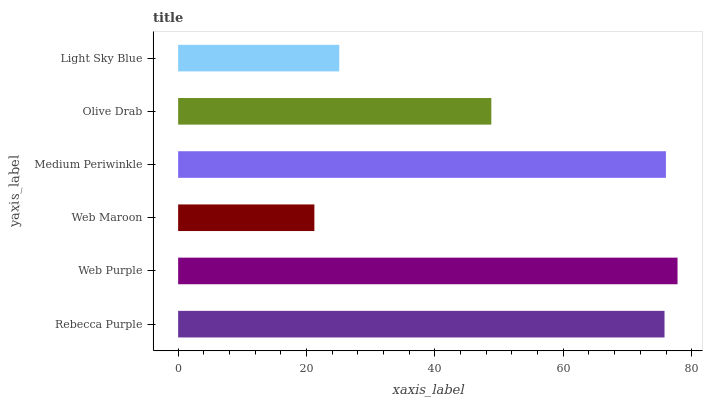Is Web Maroon the minimum?
Answer yes or no. Yes. Is Web Purple the maximum?
Answer yes or no. Yes. Is Web Purple the minimum?
Answer yes or no. No. Is Web Maroon the maximum?
Answer yes or no. No. Is Web Purple greater than Web Maroon?
Answer yes or no. Yes. Is Web Maroon less than Web Purple?
Answer yes or no. Yes. Is Web Maroon greater than Web Purple?
Answer yes or no. No. Is Web Purple less than Web Maroon?
Answer yes or no. No. Is Rebecca Purple the high median?
Answer yes or no. Yes. Is Olive Drab the low median?
Answer yes or no. Yes. Is Web Purple the high median?
Answer yes or no. No. Is Rebecca Purple the low median?
Answer yes or no. No. 